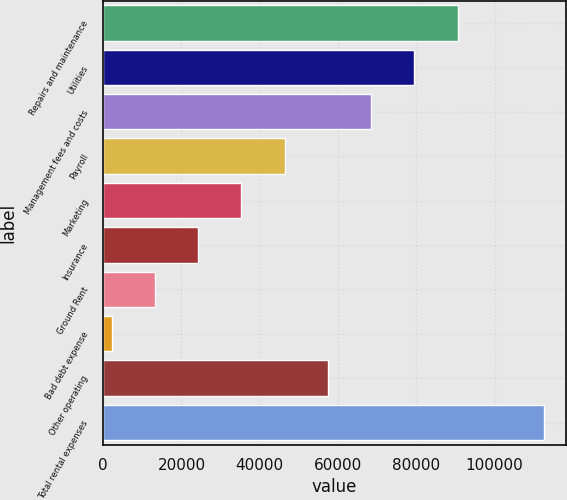Convert chart to OTSL. <chart><loc_0><loc_0><loc_500><loc_500><bar_chart><fcel>Repairs and maintenance<fcel>Utilities<fcel>Management fees and costs<fcel>Payroll<fcel>Marketing<fcel>Insurance<fcel>Ground Rent<fcel>Bad debt expense<fcel>Other operating<fcel>Total rental expenses<nl><fcel>90527.4<fcel>79483.1<fcel>68438.8<fcel>46350.2<fcel>35305.9<fcel>24261.6<fcel>13217.3<fcel>2173<fcel>57394.5<fcel>112616<nl></chart> 